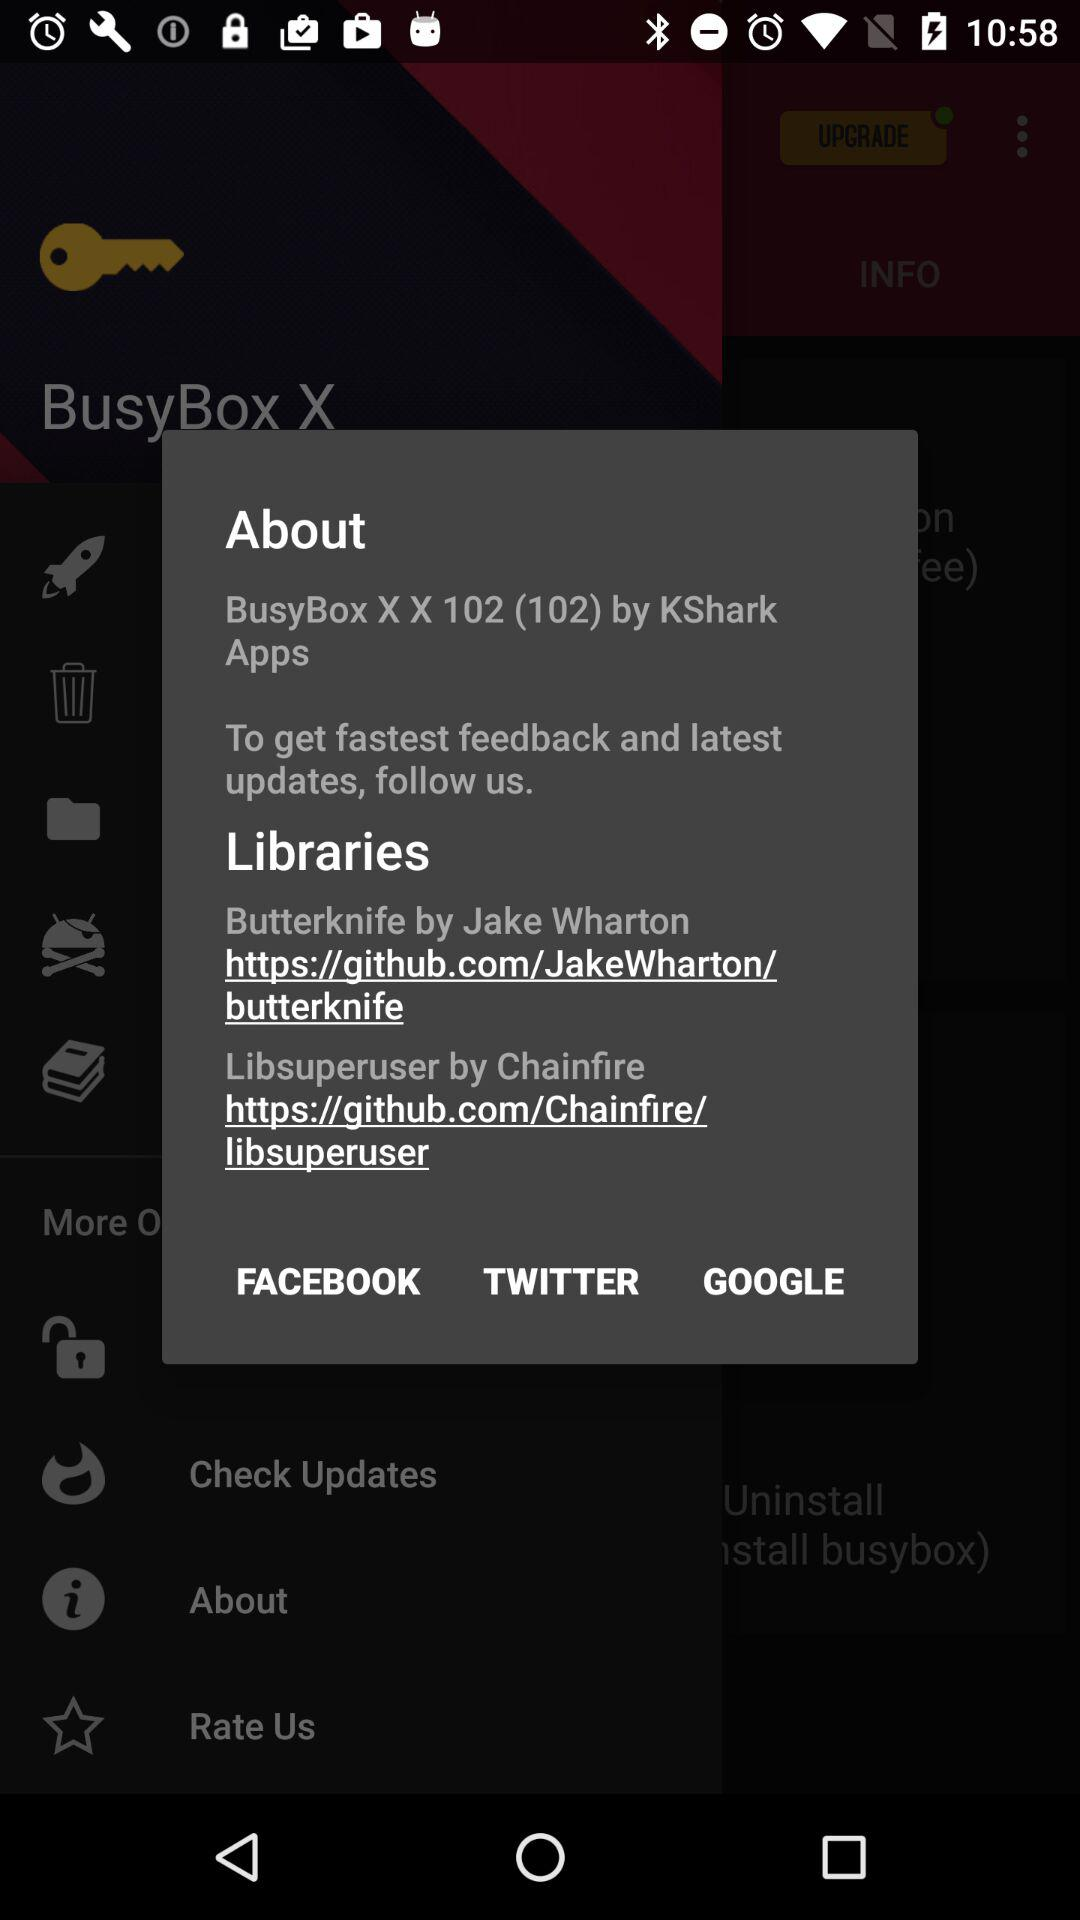What is the application name? The application name is "BusyBox X". 